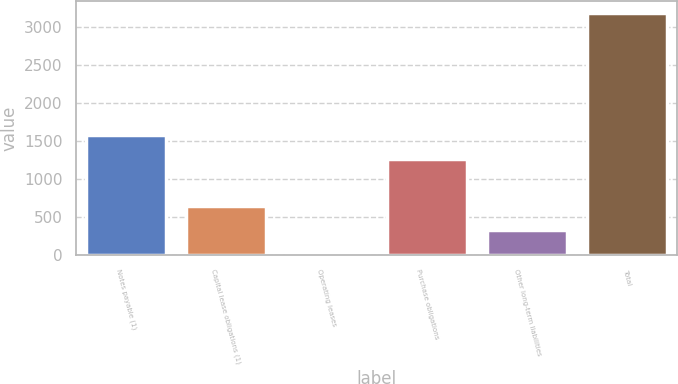<chart> <loc_0><loc_0><loc_500><loc_500><bar_chart><fcel>Notes payable (1)<fcel>Capital lease obligations (1)<fcel>Operating leases<fcel>Purchase obligations<fcel>Other long-term liabilities<fcel>Total<nl><fcel>1589.2<fcel>654.4<fcel>22<fcel>1273<fcel>338.2<fcel>3184<nl></chart> 